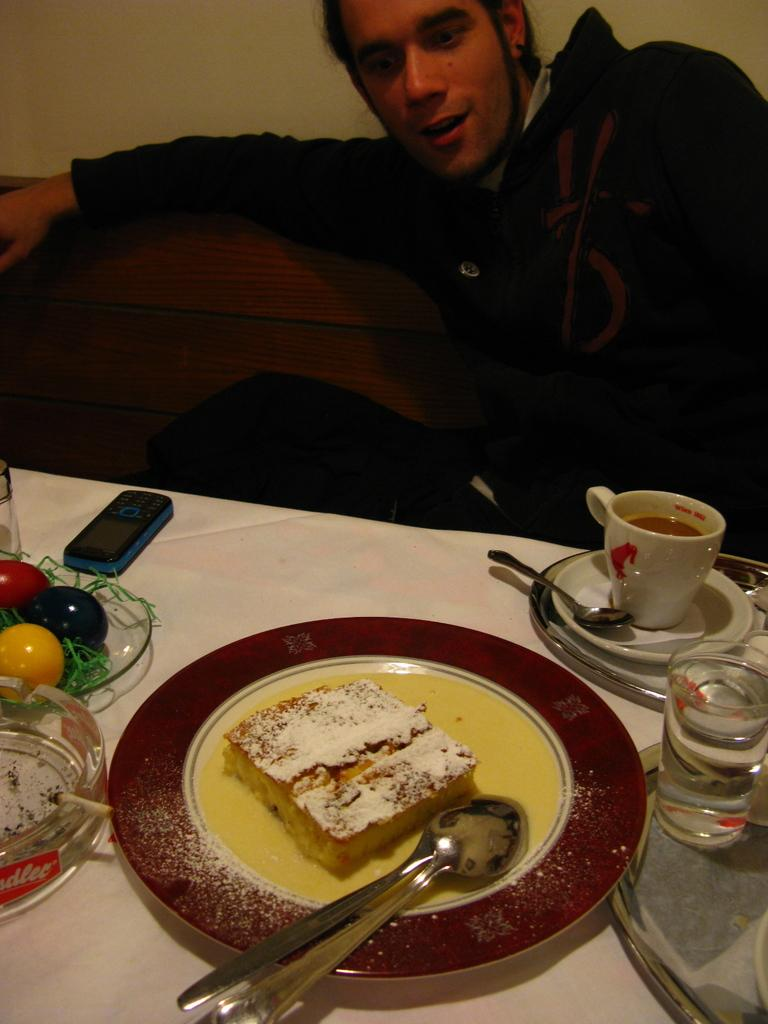What is the man in the image doing? The man is sitting in the image. What is in front of the man? There is a table in front of the man. What is on the table? There is a plate of food, 2 glasses, a spoon, and a phone on the table. How many glasses are on the table? There are 2 glasses on the table. Does the man have a tail in the image? No, the man does not have a tail in the image. Can you see the man kicking anything in the image? No, the man is not kicking anything in the image. 